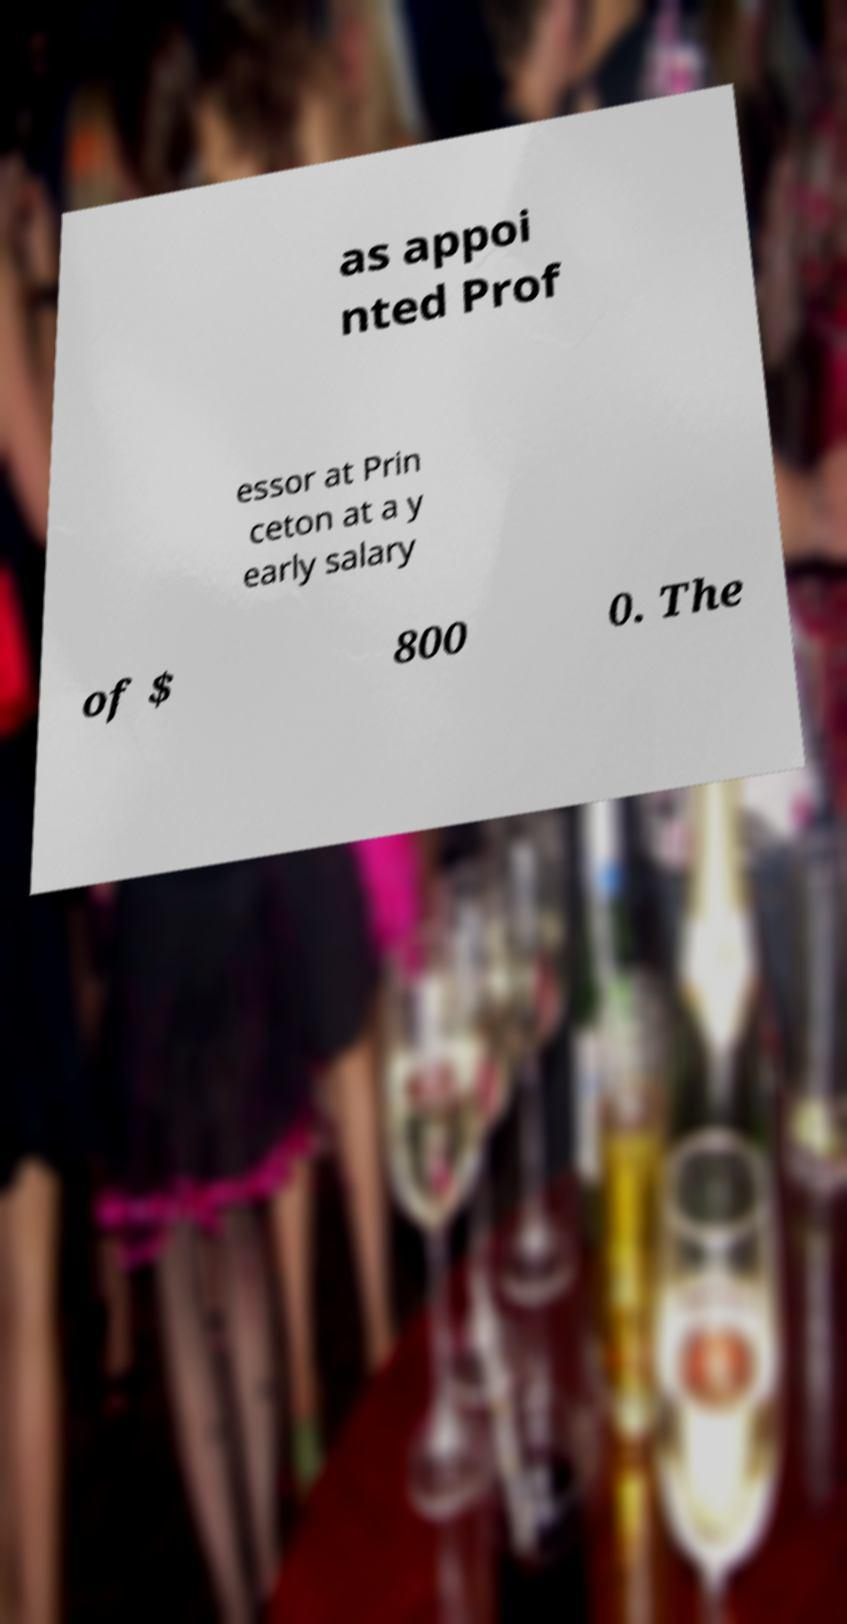Please read and relay the text visible in this image. What does it say? as appoi nted Prof essor at Prin ceton at a y early salary of $ 800 0. The 